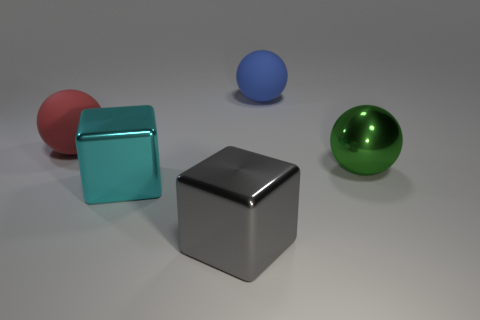Subtract all spheres. How many objects are left? 2 Subtract 1 blocks. How many blocks are left? 1 Subtract all green cubes. Subtract all red cylinders. How many cubes are left? 2 Subtract all yellow cylinders. How many gray cubes are left? 1 Subtract all red matte objects. Subtract all green shiny spheres. How many objects are left? 3 Add 3 big gray things. How many big gray things are left? 4 Add 2 matte balls. How many matte balls exist? 4 Add 1 balls. How many objects exist? 6 Subtract all cyan cubes. How many cubes are left? 1 Subtract all blue balls. How many balls are left? 2 